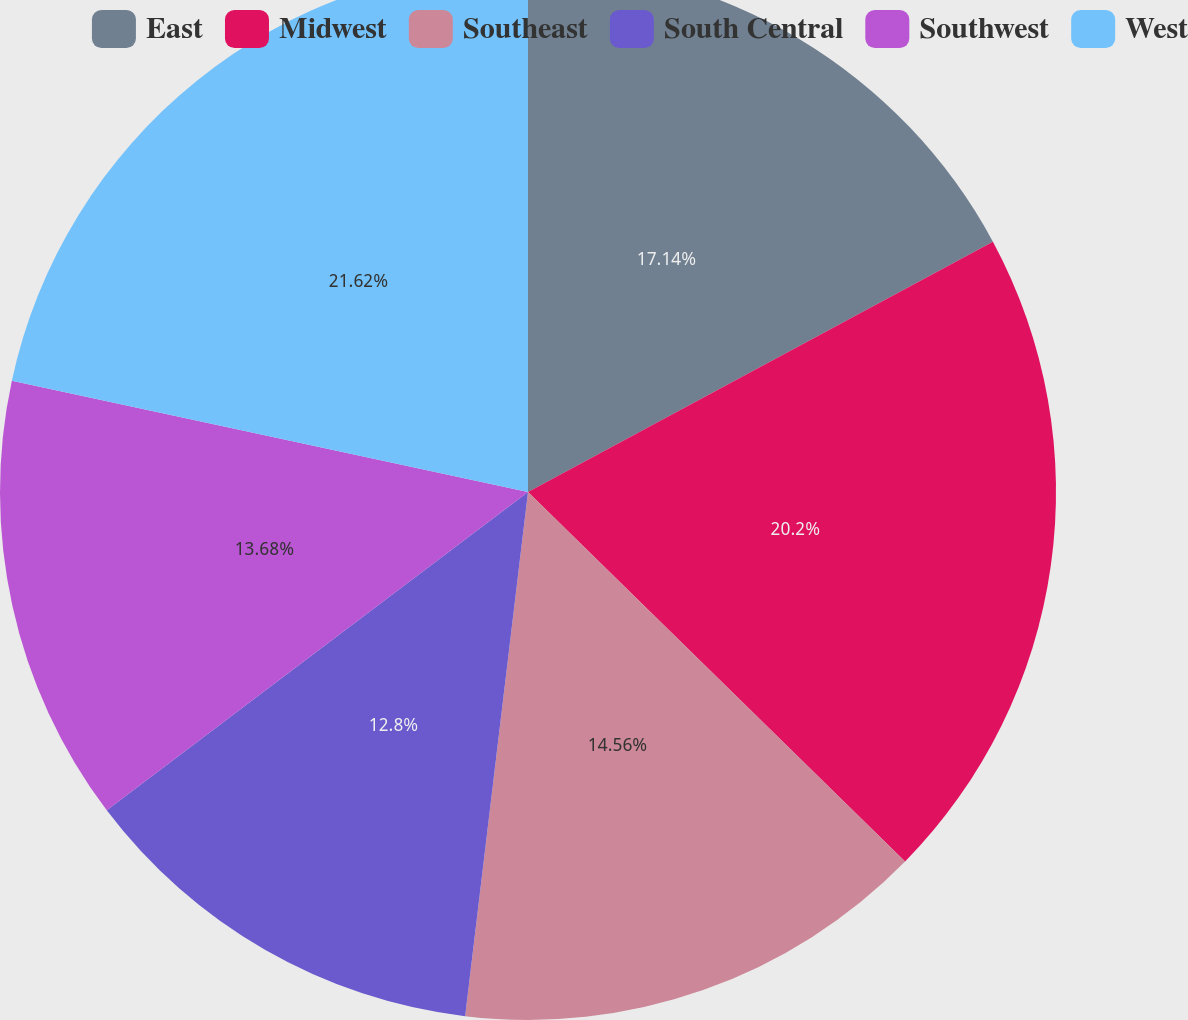Convert chart. <chart><loc_0><loc_0><loc_500><loc_500><pie_chart><fcel>East<fcel>Midwest<fcel>Southeast<fcel>South Central<fcel>Southwest<fcel>West<nl><fcel>17.14%<fcel>20.2%<fcel>14.56%<fcel>12.8%<fcel>13.68%<fcel>21.62%<nl></chart> 